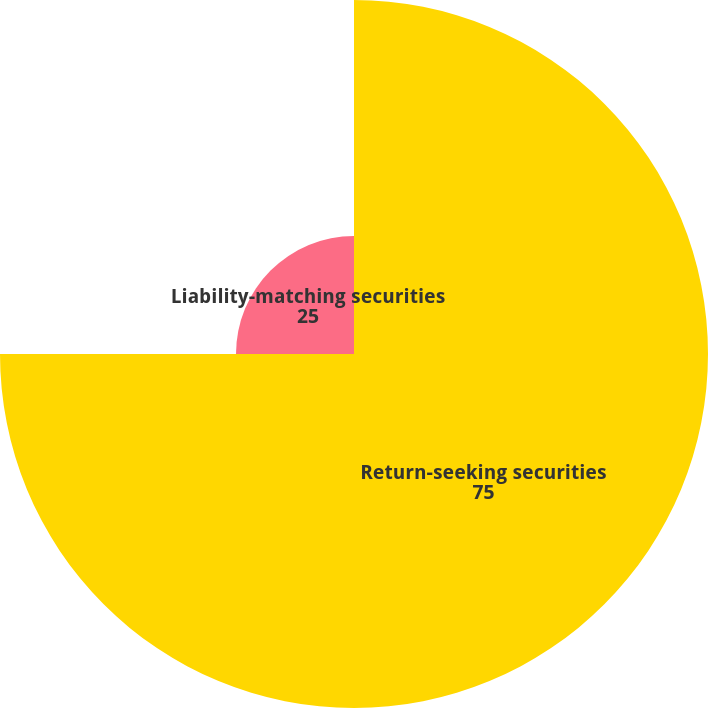<chart> <loc_0><loc_0><loc_500><loc_500><pie_chart><fcel>Return-seeking securities<fcel>Liability-matching securities<nl><fcel>75.0%<fcel>25.0%<nl></chart> 